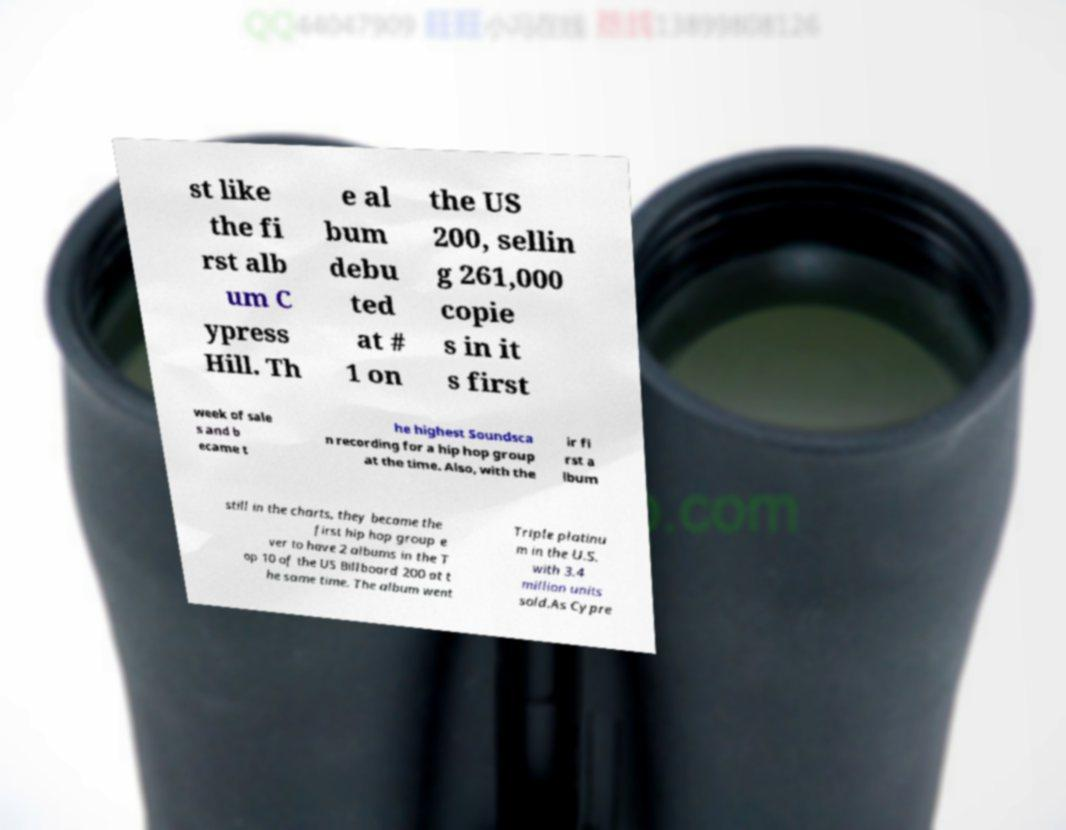Can you accurately transcribe the text from the provided image for me? st like the fi rst alb um C ypress Hill. Th e al bum debu ted at # 1 on the US 200, sellin g 261,000 copie s in it s first week of sale s and b ecame t he highest Soundsca n recording for a hip hop group at the time. Also, with the ir fi rst a lbum still in the charts, they became the first hip hop group e ver to have 2 albums in the T op 10 of the US Billboard 200 at t he same time. The album went Triple platinu m in the U.S. with 3.4 million units sold.As Cypre 